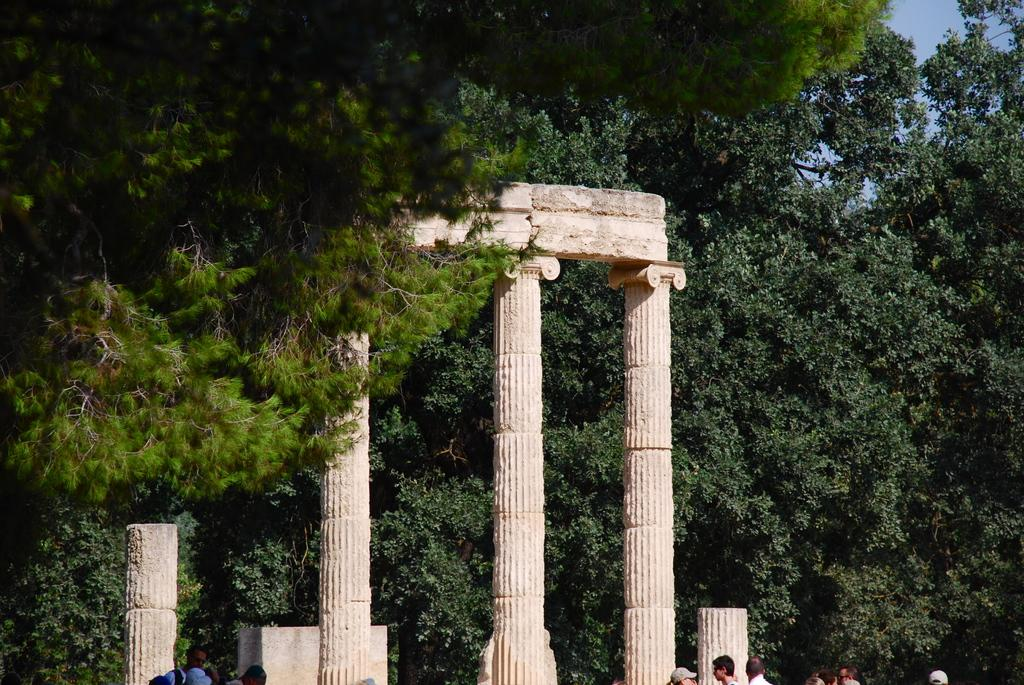What architectural features can be seen in the image? There are pillars in the image. What type of natural elements are present in the image? There are trees in the image. Who or what is present in the image? There are people in the image. What type of kite is being flown by the people in the image? There is no kite present in the image; it only features pillars, trees, and people. What design elements can be seen in the pillars in the image? The provided facts do not mention any specific design elements in the pillars, so we cannot answer this question definitively. 